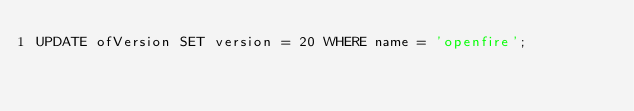Convert code to text. <code><loc_0><loc_0><loc_500><loc_500><_SQL_>UPDATE ofVersion SET version = 20 WHERE name = 'openfire';</code> 